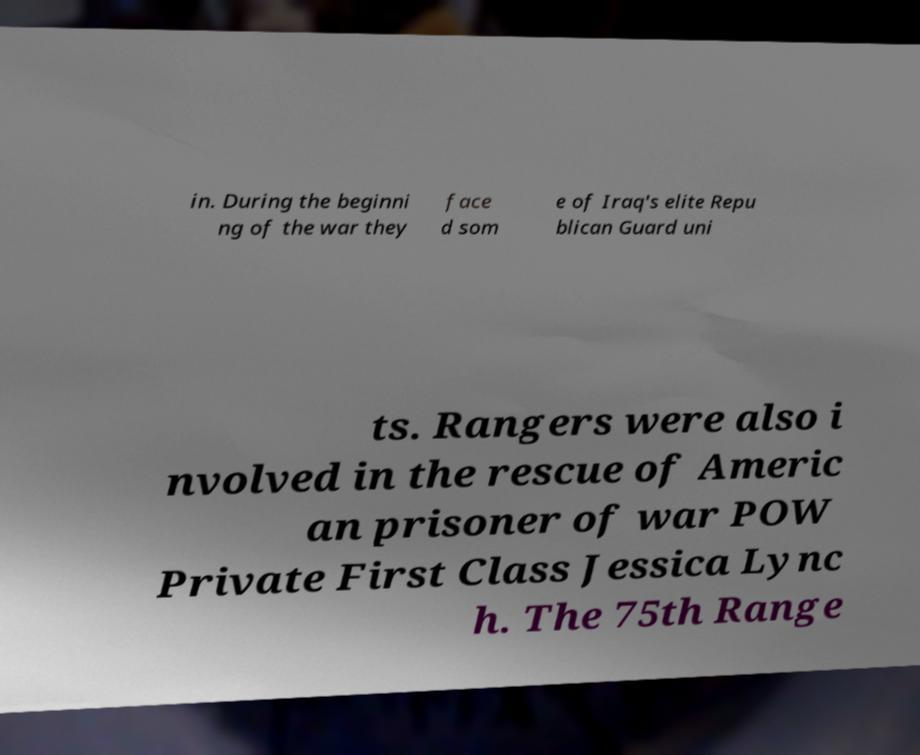What messages or text are displayed in this image? I need them in a readable, typed format. in. During the beginni ng of the war they face d som e of Iraq's elite Repu blican Guard uni ts. Rangers were also i nvolved in the rescue of Americ an prisoner of war POW Private First Class Jessica Lync h. The 75th Range 